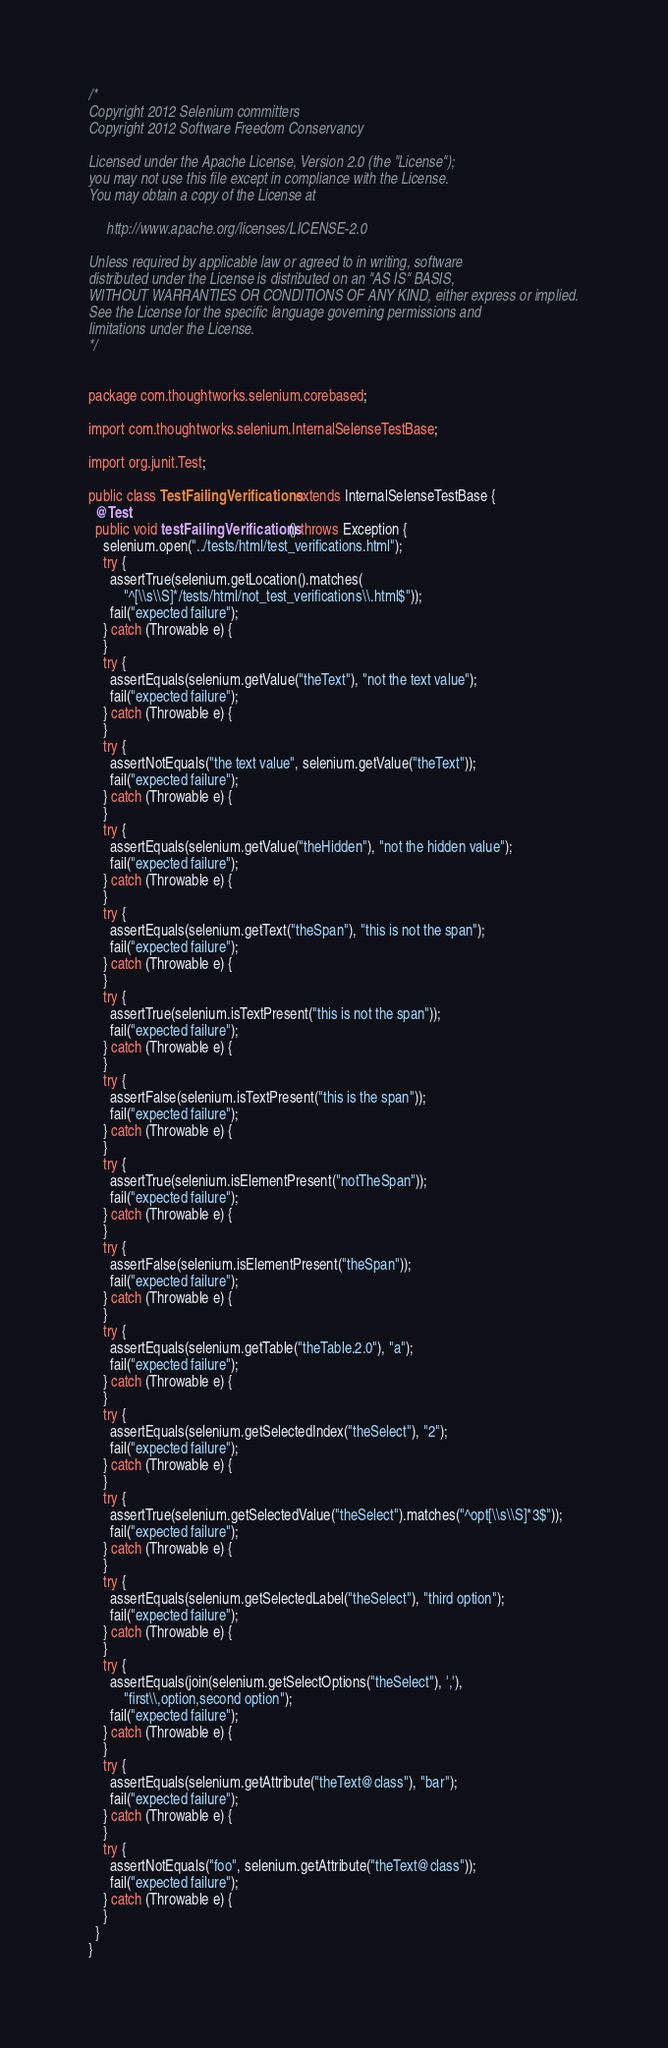Convert code to text. <code><loc_0><loc_0><loc_500><loc_500><_Java_>/*
Copyright 2012 Selenium committers
Copyright 2012 Software Freedom Conservancy

Licensed under the Apache License, Version 2.0 (the "License");
you may not use this file except in compliance with the License.
You may obtain a copy of the License at

     http://www.apache.org/licenses/LICENSE-2.0

Unless required by applicable law or agreed to in writing, software
distributed under the License is distributed on an "AS IS" BASIS,
WITHOUT WARRANTIES OR CONDITIONS OF ANY KIND, either express or implied.
See the License for the specific language governing permissions and
limitations under the License.
*/


package com.thoughtworks.selenium.corebased;

import com.thoughtworks.selenium.InternalSelenseTestBase;

import org.junit.Test;

public class TestFailingVerifications extends InternalSelenseTestBase {
  @Test
  public void testFailingVerifications() throws Exception {
    selenium.open("../tests/html/test_verifications.html");
    try {
      assertTrue(selenium.getLocation().matches(
          "^[\\s\\S]*/tests/html/not_test_verifications\\.html$"));
      fail("expected failure");
    } catch (Throwable e) {
    }
    try {
      assertEquals(selenium.getValue("theText"), "not the text value");
      fail("expected failure");
    } catch (Throwable e) {
    }
    try {
      assertNotEquals("the text value", selenium.getValue("theText"));
      fail("expected failure");
    } catch (Throwable e) {
    }
    try {
      assertEquals(selenium.getValue("theHidden"), "not the hidden value");
      fail("expected failure");
    } catch (Throwable e) {
    }
    try {
      assertEquals(selenium.getText("theSpan"), "this is not the span");
      fail("expected failure");
    } catch (Throwable e) {
    }
    try {
      assertTrue(selenium.isTextPresent("this is not the span"));
      fail("expected failure");
    } catch (Throwable e) {
    }
    try {
      assertFalse(selenium.isTextPresent("this is the span"));
      fail("expected failure");
    } catch (Throwable e) {
    }
    try {
      assertTrue(selenium.isElementPresent("notTheSpan"));
      fail("expected failure");
    } catch (Throwable e) {
    }
    try {
      assertFalse(selenium.isElementPresent("theSpan"));
      fail("expected failure");
    } catch (Throwable e) {
    }
    try {
      assertEquals(selenium.getTable("theTable.2.0"), "a");
      fail("expected failure");
    } catch (Throwable e) {
    }
    try {
      assertEquals(selenium.getSelectedIndex("theSelect"), "2");
      fail("expected failure");
    } catch (Throwable e) {
    }
    try {
      assertTrue(selenium.getSelectedValue("theSelect").matches("^opt[\\s\\S]*3$"));
      fail("expected failure");
    } catch (Throwable e) {
    }
    try {
      assertEquals(selenium.getSelectedLabel("theSelect"), "third option");
      fail("expected failure");
    } catch (Throwable e) {
    }
    try {
      assertEquals(join(selenium.getSelectOptions("theSelect"), ','),
          "first\\,option,second option");
      fail("expected failure");
    } catch (Throwable e) {
    }
    try {
      assertEquals(selenium.getAttribute("theText@class"), "bar");
      fail("expected failure");
    } catch (Throwable e) {
    }
    try {
      assertNotEquals("foo", selenium.getAttribute("theText@class"));
      fail("expected failure");
    } catch (Throwable e) {
    }
  }
}
</code> 